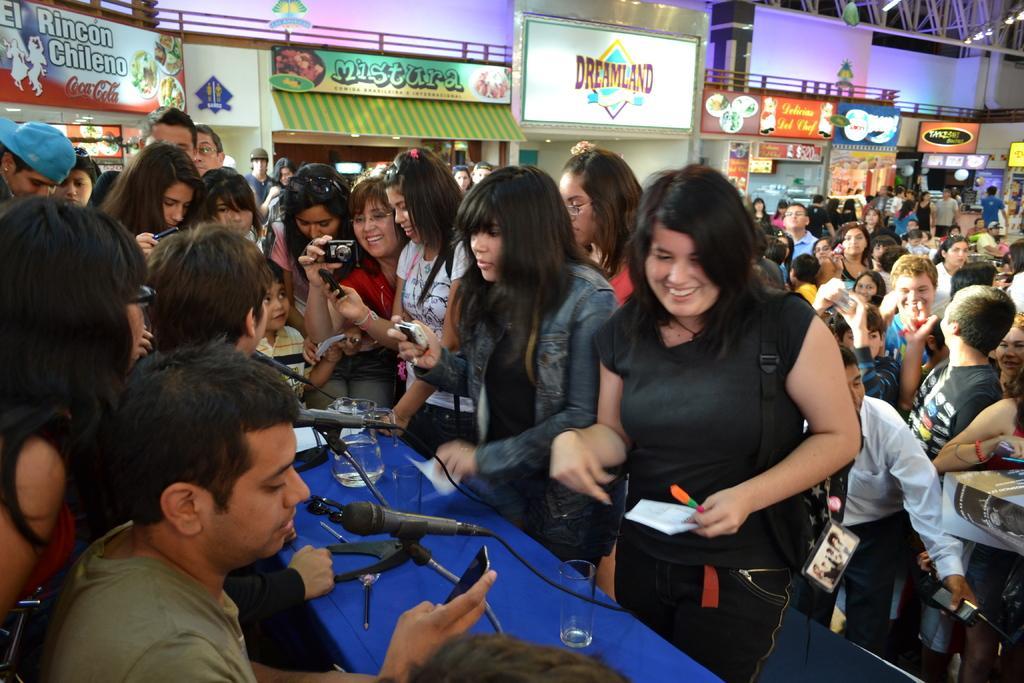How would you summarize this image in a sentence or two? In this image I can see number of people. I can see few of them are holding cameras. I can also see few glasses, a jug, few mics and in background I can see number of boards. On these words I can see something is written. 